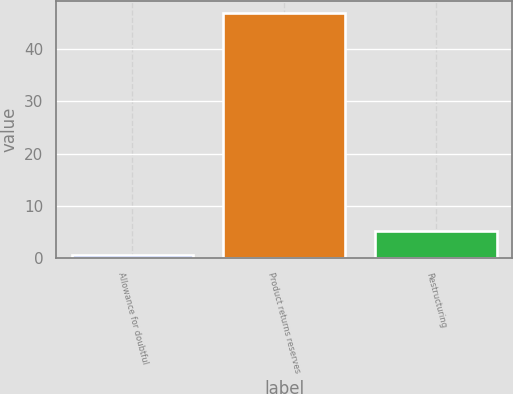<chart> <loc_0><loc_0><loc_500><loc_500><bar_chart><fcel>Allowance for doubtful<fcel>Product returns reserves<fcel>Restructuring<nl><fcel>0.6<fcel>46.8<fcel>5.22<nl></chart> 